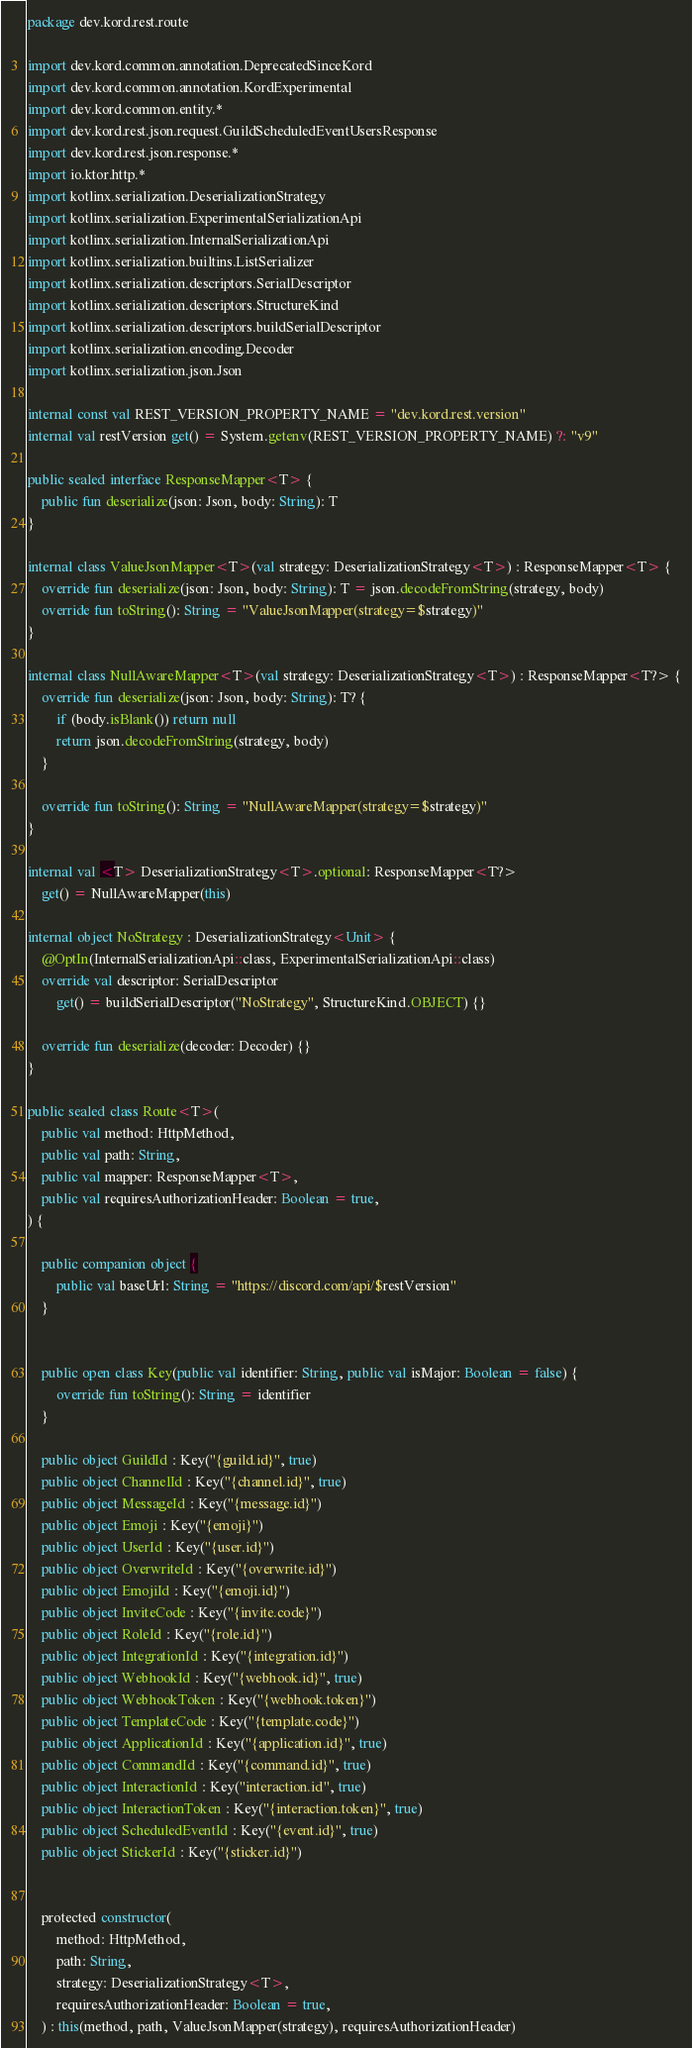Convert code to text. <code><loc_0><loc_0><loc_500><loc_500><_Kotlin_>package dev.kord.rest.route

import dev.kord.common.annotation.DeprecatedSinceKord
import dev.kord.common.annotation.KordExperimental
import dev.kord.common.entity.*
import dev.kord.rest.json.request.GuildScheduledEventUsersResponse
import dev.kord.rest.json.response.*
import io.ktor.http.*
import kotlinx.serialization.DeserializationStrategy
import kotlinx.serialization.ExperimentalSerializationApi
import kotlinx.serialization.InternalSerializationApi
import kotlinx.serialization.builtins.ListSerializer
import kotlinx.serialization.descriptors.SerialDescriptor
import kotlinx.serialization.descriptors.StructureKind
import kotlinx.serialization.descriptors.buildSerialDescriptor
import kotlinx.serialization.encoding.Decoder
import kotlinx.serialization.json.Json

internal const val REST_VERSION_PROPERTY_NAME = "dev.kord.rest.version"
internal val restVersion get() = System.getenv(REST_VERSION_PROPERTY_NAME) ?: "v9"

public sealed interface ResponseMapper<T> {
    public fun deserialize(json: Json, body: String): T
}

internal class ValueJsonMapper<T>(val strategy: DeserializationStrategy<T>) : ResponseMapper<T> {
    override fun deserialize(json: Json, body: String): T = json.decodeFromString(strategy, body)
    override fun toString(): String = "ValueJsonMapper(strategy=$strategy)"
}

internal class NullAwareMapper<T>(val strategy: DeserializationStrategy<T>) : ResponseMapper<T?> {
    override fun deserialize(json: Json, body: String): T? {
        if (body.isBlank()) return null
        return json.decodeFromString(strategy, body)
    }

    override fun toString(): String = "NullAwareMapper(strategy=$strategy)"
}

internal val <T> DeserializationStrategy<T>.optional: ResponseMapper<T?>
    get() = NullAwareMapper(this)

internal object NoStrategy : DeserializationStrategy<Unit> {
    @OptIn(InternalSerializationApi::class, ExperimentalSerializationApi::class)
    override val descriptor: SerialDescriptor
        get() = buildSerialDescriptor("NoStrategy", StructureKind.OBJECT) {}

    override fun deserialize(decoder: Decoder) {}
}

public sealed class Route<T>(
    public val method: HttpMethod,
    public val path: String,
    public val mapper: ResponseMapper<T>,
    public val requiresAuthorizationHeader: Boolean = true,
) {

    public companion object {
        public val baseUrl: String = "https://discord.com/api/$restVersion"
    }


    public open class Key(public val identifier: String, public val isMajor: Boolean = false) {
        override fun toString(): String = identifier
    }

    public object GuildId : Key("{guild.id}", true)
    public object ChannelId : Key("{channel.id}", true)
    public object MessageId : Key("{message.id}")
    public object Emoji : Key("{emoji}")
    public object UserId : Key("{user.id}")
    public object OverwriteId : Key("{overwrite.id}")
    public object EmojiId : Key("{emoji.id}")
    public object InviteCode : Key("{invite.code}")
    public object RoleId : Key("{role.id}")
    public object IntegrationId : Key("{integration.id}")
    public object WebhookId : Key("{webhook.id}", true)
    public object WebhookToken : Key("{webhook.token}")
    public object TemplateCode : Key("{template.code}")
    public object ApplicationId : Key("{application.id}", true)
    public object CommandId : Key("{command.id}", true)
    public object InteractionId : Key("interaction.id", true)
    public object InteractionToken : Key("{interaction.token}", true)
    public object ScheduledEventId : Key("{event.id}", true)
    public object StickerId : Key("{sticker.id}")


    protected constructor(
        method: HttpMethod,
        path: String,
        strategy: DeserializationStrategy<T>,
        requiresAuthorizationHeader: Boolean = true,
    ) : this(method, path, ValueJsonMapper(strategy), requiresAuthorizationHeader)
</code> 